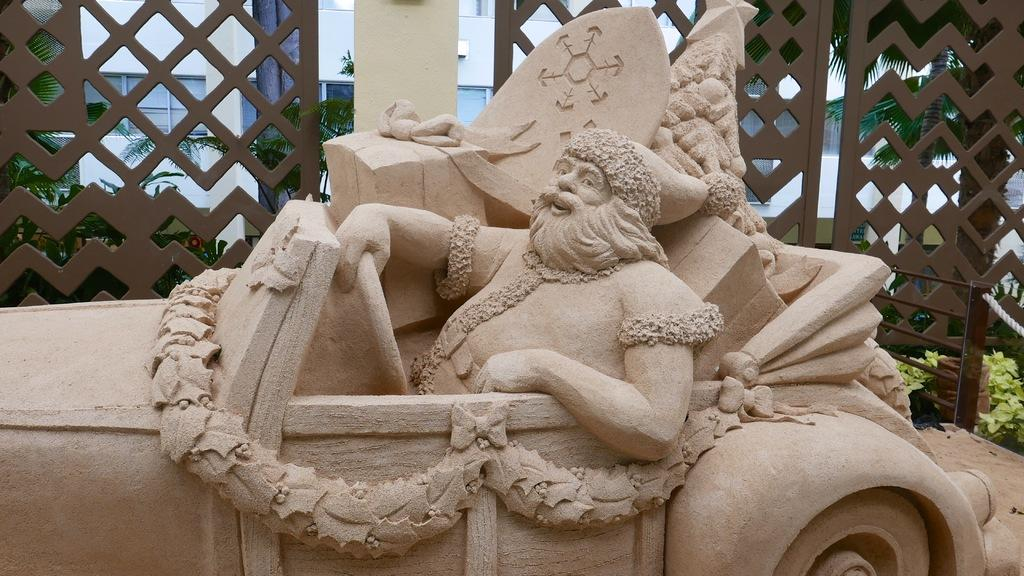What is the main subject of the image? There is a statue in the image. What is the statue sitting on? The statue is sitting on a vehicle. What can be seen in the background of the image? There is a railing, trees, and a building in the background of the image. What is the color of the sky in the image? The sky is blue in the image. What type of interest is the statue earning while sitting on the vehicle in the image? The image does not provide any information about the statue earning interest, as it is not related to the facts provided. Can you see any waste or garbage in the image? There is no mention of waste or garbage in the image, so it cannot be determined from the facts provided. 